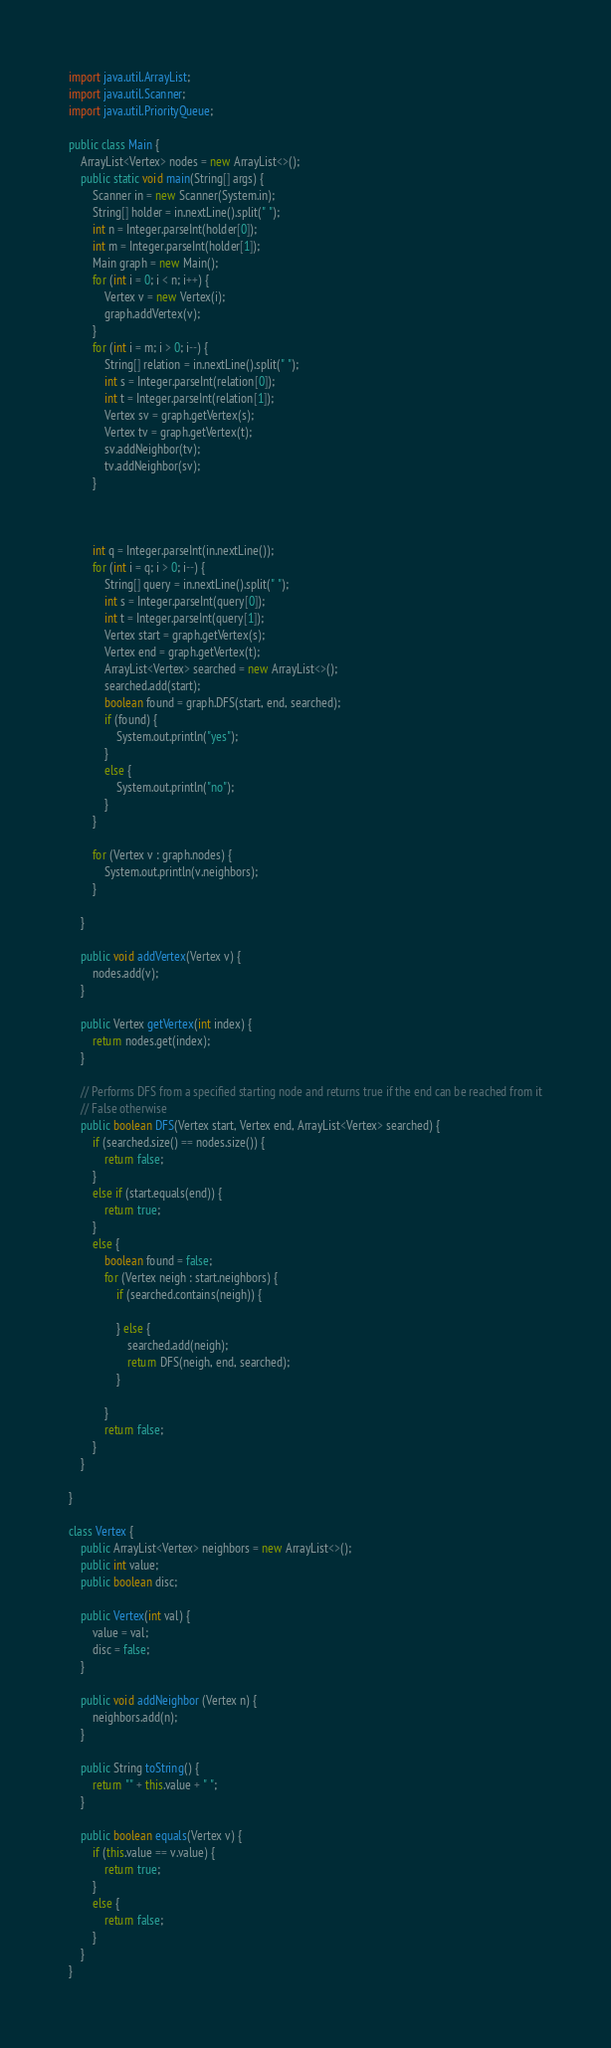<code> <loc_0><loc_0><loc_500><loc_500><_Java_>
import java.util.ArrayList;
import java.util.Scanner;
import java.util.PriorityQueue;

public class Main {
	ArrayList<Vertex> nodes = new ArrayList<>();
	public static void main(String[] args) {
		Scanner in = new Scanner(System.in);
		String[] holder = in.nextLine().split(" ");
		int n = Integer.parseInt(holder[0]);
		int m = Integer.parseInt(holder[1]);
		Main graph = new Main();
		for (int i = 0; i < n; i++) {
			Vertex v = new Vertex(i);
			graph.addVertex(v);
		}
		for (int i = m; i > 0; i--) {
			String[] relation = in.nextLine().split(" ");
			int s = Integer.parseInt(relation[0]);
			int t = Integer.parseInt(relation[1]);
			Vertex sv = graph.getVertex(s);
			Vertex tv = graph.getVertex(t);
			sv.addNeighbor(tv);
			tv.addNeighbor(sv);
		}
		
		
		
		int q = Integer.parseInt(in.nextLine());
		for (int i = q; i > 0; i--) {
			String[] query = in.nextLine().split(" ");
			int s = Integer.parseInt(query[0]);
			int t = Integer.parseInt(query[1]);
			Vertex start = graph.getVertex(s);
			Vertex end = graph.getVertex(t);
			ArrayList<Vertex> searched = new ArrayList<>();
			searched.add(start);
			boolean found = graph.DFS(start, end, searched);
			if (found) {
				System.out.println("yes");
			}
			else {
				System.out.println("no");
			}
		}
		
		for (Vertex v : graph.nodes) {
			System.out.println(v.neighbors);
		}
		
	}	
		
	public void addVertex(Vertex v) {
		nodes.add(v);
	}
	
	public Vertex getVertex(int index) {
		return nodes.get(index);
	}
	
	// Performs DFS from a specified starting node and returns true if the end can be reached from it
	// False otherwise
	public boolean DFS(Vertex start, Vertex end, ArrayList<Vertex> searched) {	
		if (searched.size() == nodes.size()) {
			return false;
		}
		else if (start.equals(end)) {
			return true;
		}
		else {
			boolean found = false;
			for (Vertex neigh : start.neighbors) {
				if (searched.contains(neigh)) {
					
				} else {
					searched.add(neigh);
					return DFS(neigh, end, searched);
				}
				
			}
			return false;
		}
	}
	
}

class Vertex {
	public ArrayList<Vertex> neighbors = new ArrayList<>();
	public int value;
	public boolean disc;
	
	public Vertex(int val) {
		value = val;
		disc = false;
	}
	
	public void addNeighbor (Vertex n) {
		neighbors.add(n);
	}
	
	public String toString() {
		return "" + this.value + " ";
	}
	
	public boolean equals(Vertex v) {
		if (this.value == v.value) {
			return true;
		}
		else {
			return false;
		}
	}
}


</code> 